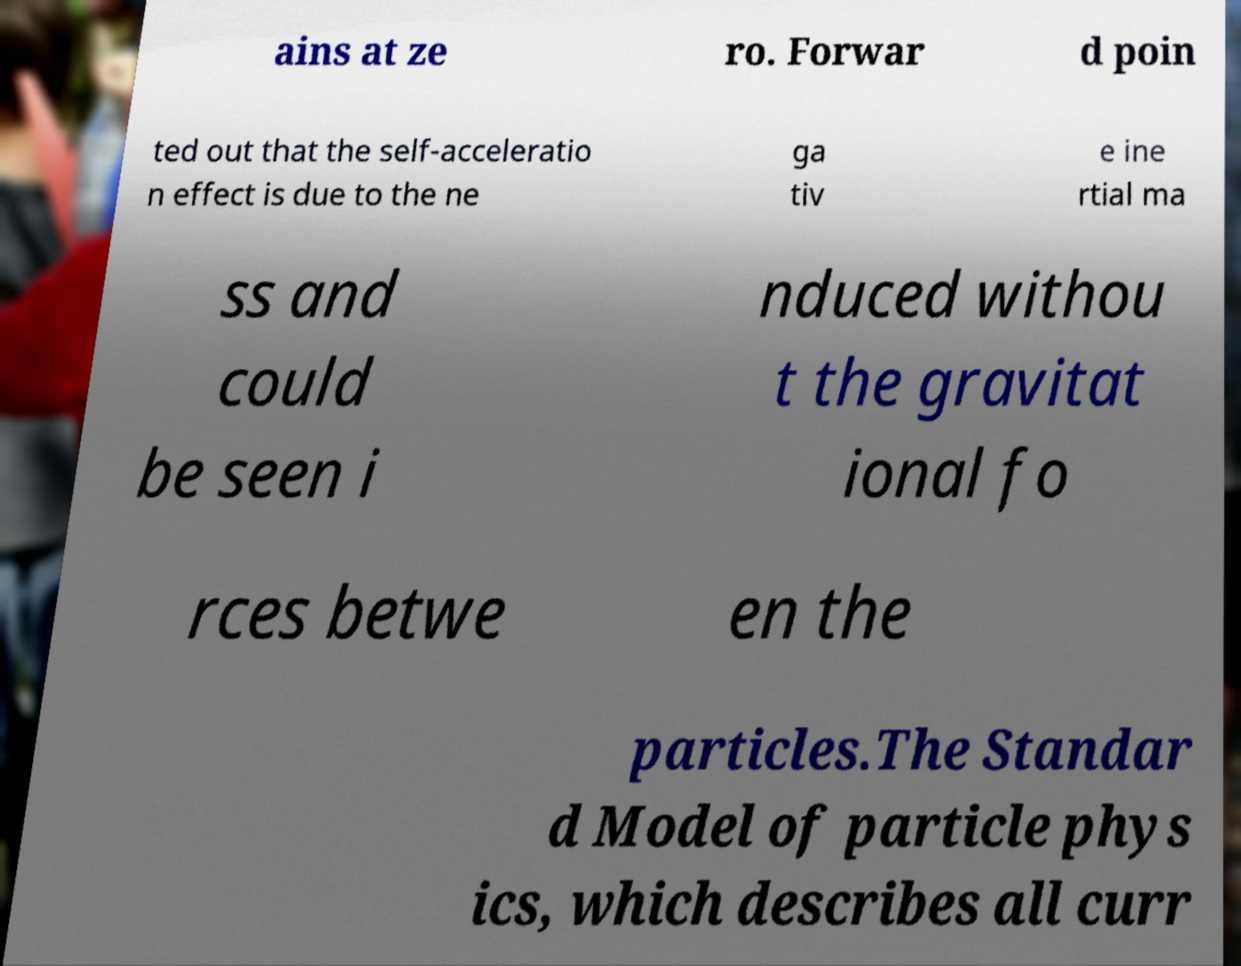I need the written content from this picture converted into text. Can you do that? ains at ze ro. Forwar d poin ted out that the self-acceleratio n effect is due to the ne ga tiv e ine rtial ma ss and could be seen i nduced withou t the gravitat ional fo rces betwe en the particles.The Standar d Model of particle phys ics, which describes all curr 